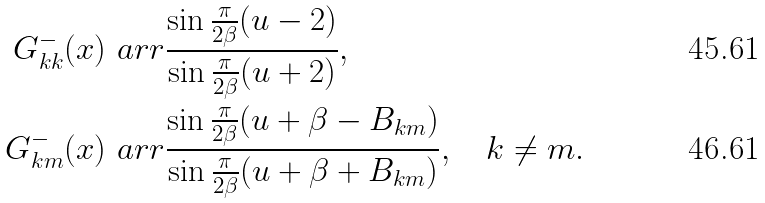Convert formula to latex. <formula><loc_0><loc_0><loc_500><loc_500>G ^ { - } _ { k k } ( x ) & \ a r r \frac { \sin \frac { \pi } { 2 \beta } ( u - 2 ) } { \sin \frac { \pi } { 2 \beta } ( u + 2 ) } , \\ G ^ { - } _ { k m } ( x ) & \ a r r \frac { \sin \frac { \pi } { 2 \beta } ( u + \beta - B _ { k m } ) } { \sin \frac { \pi } { 2 \beta } ( u + \beta + B _ { k m } ) } , \quad k \neq m .</formula> 